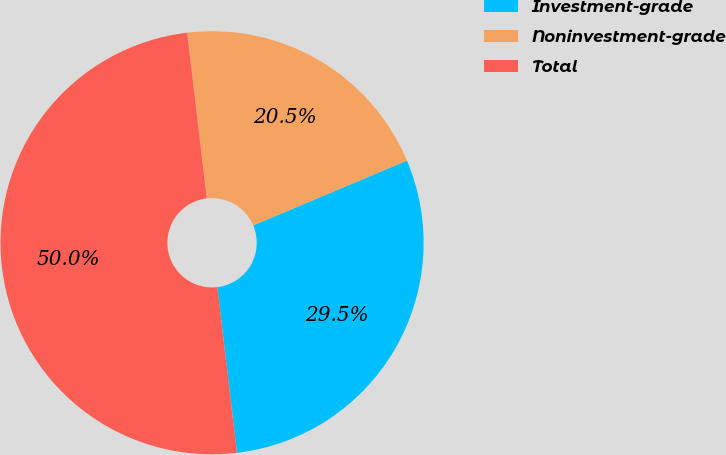<chart> <loc_0><loc_0><loc_500><loc_500><pie_chart><fcel>Investment-grade<fcel>Noninvestment-grade<fcel>Total<nl><fcel>29.47%<fcel>20.53%<fcel>50.0%<nl></chart> 